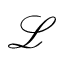<formula> <loc_0><loc_0><loc_500><loc_500>\mathcal { L }</formula> 